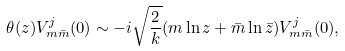Convert formula to latex. <formula><loc_0><loc_0><loc_500><loc_500>\theta ( z ) V ^ { j } _ { m \bar { m } } ( 0 ) \sim - i \sqrt { \frac { 2 } { k } } ( m \ln z + \bar { m } \ln \bar { z } ) V ^ { j } _ { m \bar { m } } ( 0 ) ,</formula> 